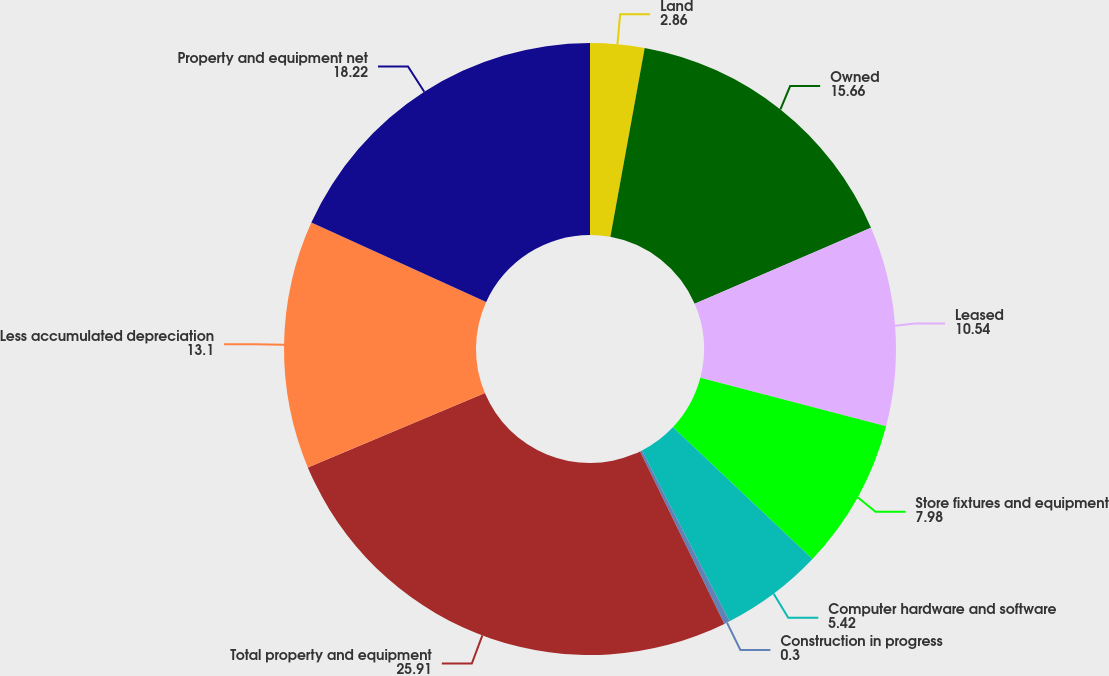Convert chart. <chart><loc_0><loc_0><loc_500><loc_500><pie_chart><fcel>Land<fcel>Owned<fcel>Leased<fcel>Store fixtures and equipment<fcel>Computer hardware and software<fcel>Construction in progress<fcel>Total property and equipment<fcel>Less accumulated depreciation<fcel>Property and equipment net<nl><fcel>2.86%<fcel>15.66%<fcel>10.54%<fcel>7.98%<fcel>5.42%<fcel>0.3%<fcel>25.91%<fcel>13.1%<fcel>18.22%<nl></chart> 